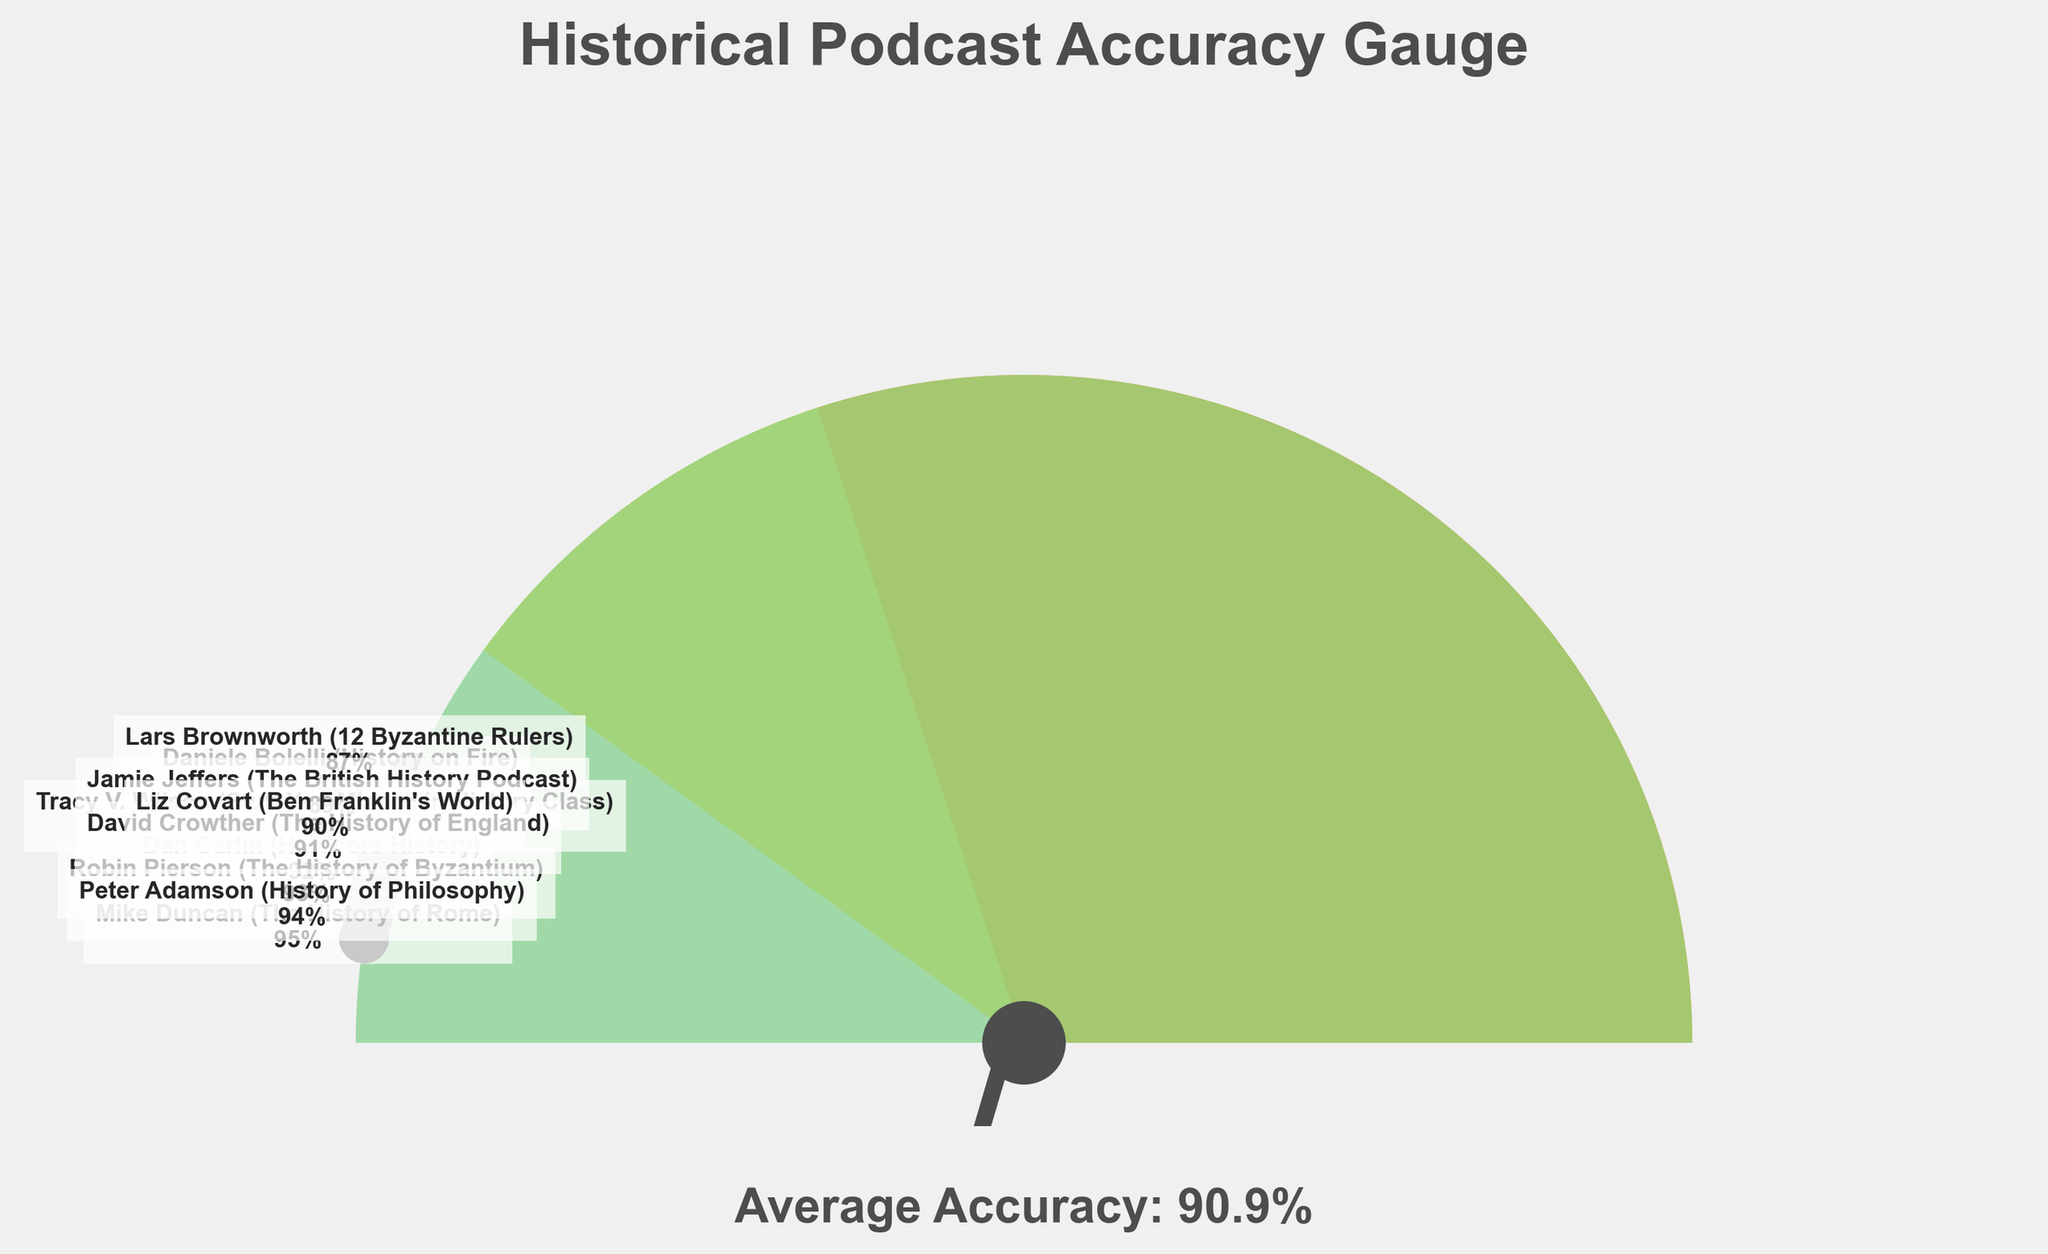How many historians achieved an accuracy score of 90% or above? By looking at the individual accuracy scores labeled on the gauge chart, we can count the historians with scores of 90% or higher. These historians and their scores are  Dan Carlin (92), Mike Duncan (95), Tracy V. Wilson (90), Robin Pierson (93), David Crowther (91), Peter Adamson (94), and Liz Covart (90).
Answer: 7 What is the average accuracy score of the historians? The average accuracy score is provided at the bottom of the gauge chart, which says "Average Accuracy: 90.9%." This is calculated by summing all individual accuracy scores and dividing by the number of historians.
Answer: 90.9% Who has the highest accuracy score? Among the labeled data points, Mike Duncan (The History of Rome) has the highest score, which is 95%.
Answer: Mike Duncan Which portion of the gauge chart appears in green, and what does it represent? The green portion of the gauge chart represents accuracy scores from 80% to 100%. This is visible because it covers the latter part of the gauge, indicating a high level of accuracy.
Answer: 80% to 100% What is the range of accuracy scores on the gauge? By looking at the labeled data points, we can identify the minimum and maximum accuracy scores, which are 87% (Lars Brownworth) and 95% (Mike Duncan). The range is therefore 95% - 87% = 8%.
Answer: 8% Is the average accuracy closer to the highest or lowest score? The average accuracy is 90.9%, which is closer to the lowest score (87%) than it is to the highest score (95%). The distance to the lowest score is 90.9 - 87 = 3.9, while the distance to the highest score is 95 - 90.9 = 4.1.
Answer: Closest to the lowest score What is the accuracy score of Dan Carlin? Dan Carlin's accuracy score is labeled directly on the gauge chart, showing 92%.
Answer: 92% How many data points are there on the gauge chart? Each labeled historian represents a data point on the gauge chart. By counting the names, we identify that there are 10 data points in total.
Answer: 10 Which two historians have the closest accuracy scores, and what are they? By examining the labeled data points, Tracy V. Wilson (Stuff You Missed in History Class) and Liz Covart (Ben Franklin's World) both achieved an accuracy score of 90%, which makes their scores the closest.
Answer: Tracy V. Wilson and Liz Covart (90%) Which historians fall within the yellow portion of the gauge chart? The yellow portion of the gauge represents accuracy scores between 60% and 80%. None of the historians fall within this range, as all have scores above 87%.
Answer: None What visual element represents the average accuracy score? The average accuracy score is represented by a needle on the gauge chart, and it points to the average score indicated by a rectangle patch.
Answer: Needle 